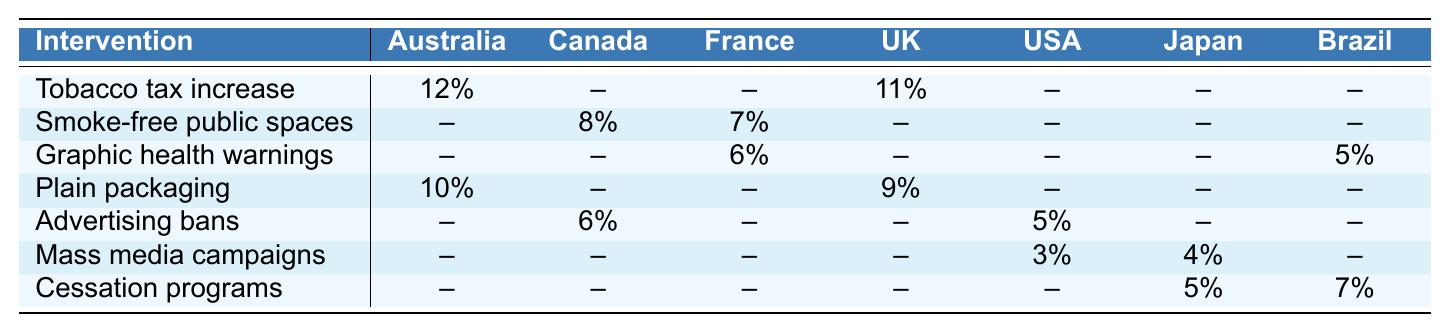What is the reduction rate of tobacco tax increase in Australia? The table shows that the reduction rate for the tobacco tax increase intervention in Australia is listed as 12%.
Answer: 12% Which country has the highest reduction rate from a tobacco tax increase? According to the table, the highest reduction rate from a tobacco tax increase is 12% in Australia.
Answer: Australia Is there any country that has a reduction rate for mass media campaigns greater than 3%? The table illustrates that Japan has a 4% reduction rate for mass media campaigns, which is indeed greater than 3%.
Answer: Yes What is the average reduction rate for the plain packaging intervention across the countries listed? The reduction rates for plain packaging are 10% in Australia and 9% in the United Kingdom. To find the average, we sum these rates (10 + 9 = 19) and divide by 2, resulting in an average of 9.5%.
Answer: 9.5% Which intervention has the lowest recorded reduction rate among the countries? By reviewing the table, mass media campaigns in the United States have the lowest reduction rate at 3%.
Answer: 3% How many countries have a reduction rate recorded for graphic health warnings? The table indicates that graphic health warnings have reduction rates listed for two countries: France (6%) and Brazil (5%).
Answer: 2 Is there a country that implemented both advertising bans and smoke-free public spaces? From the table, Canada is the only country that shows reduction rates for both advertising bans (6%) and smoke-free public spaces (8%).
Answer: Yes What is the total reduction rate from tobacco tax increases across the countries listed in the table? The total reduction rate from tobacco tax increases is calculated by adding the rates from Australia (12%) and the United Kingdom (11%), totaling 23%.
Answer: 23% Are there any countries that record the same reduction rate for two different interventions? Upon reviewing the table, Brazil has the same reduction rate of 5% for both graphic health warnings and cessation programs, indicating a match.
Answer: Yes What intervention has shown to be effective in the United States, based on the table? According to the table, the advertising bans intervention has shown a 5% reduction rate in the United States.
Answer: Advertising bans 